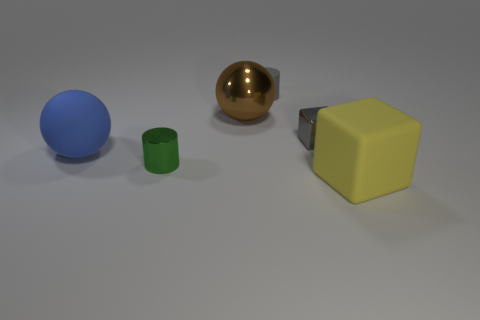There is a metal object that is the same color as the small rubber thing; what is its shape?
Give a very brief answer. Cube. There is a matte ball; does it have the same size as the metal object that is in front of the blue matte ball?
Give a very brief answer. No. What number of other things are the same shape as the big brown shiny thing?
Offer a terse response. 1. The blue object that is made of the same material as the small gray cylinder is what shape?
Ensure brevity in your answer.  Sphere. Are there any cyan cylinders?
Offer a terse response. No. Is the number of gray cubes that are left of the large yellow block less than the number of tiny cylinders left of the small gray shiny block?
Your response must be concise. Yes. What is the shape of the matte thing in front of the blue matte thing?
Make the answer very short. Cube. Is the material of the tiny gray cylinder the same as the large blue ball?
Provide a succinct answer. Yes. There is a large yellow thing that is the same shape as the gray shiny object; what is it made of?
Provide a succinct answer. Rubber. Is the number of tiny green shiny things that are behind the tiny matte cylinder less than the number of tiny gray cylinders?
Ensure brevity in your answer.  Yes. 